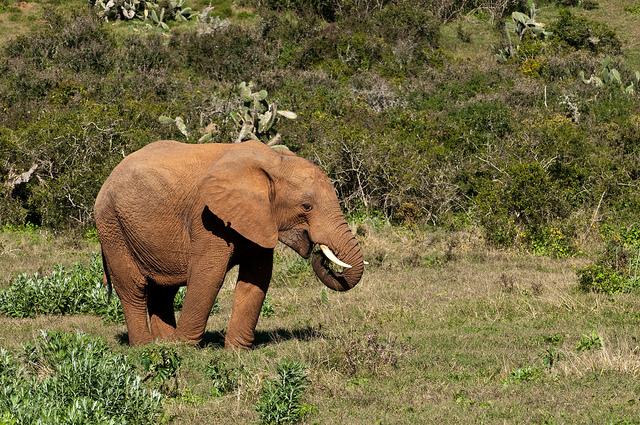What color is the elephant?
Concise answer only. Brown. The animal an adult?
Write a very short answer. Yes. Does the animal have tusks?
Quick response, please. Yes. Is the elephant African or Indian?
Concise answer only. African. Does the elephant look happy?
Short answer required. Yes. 